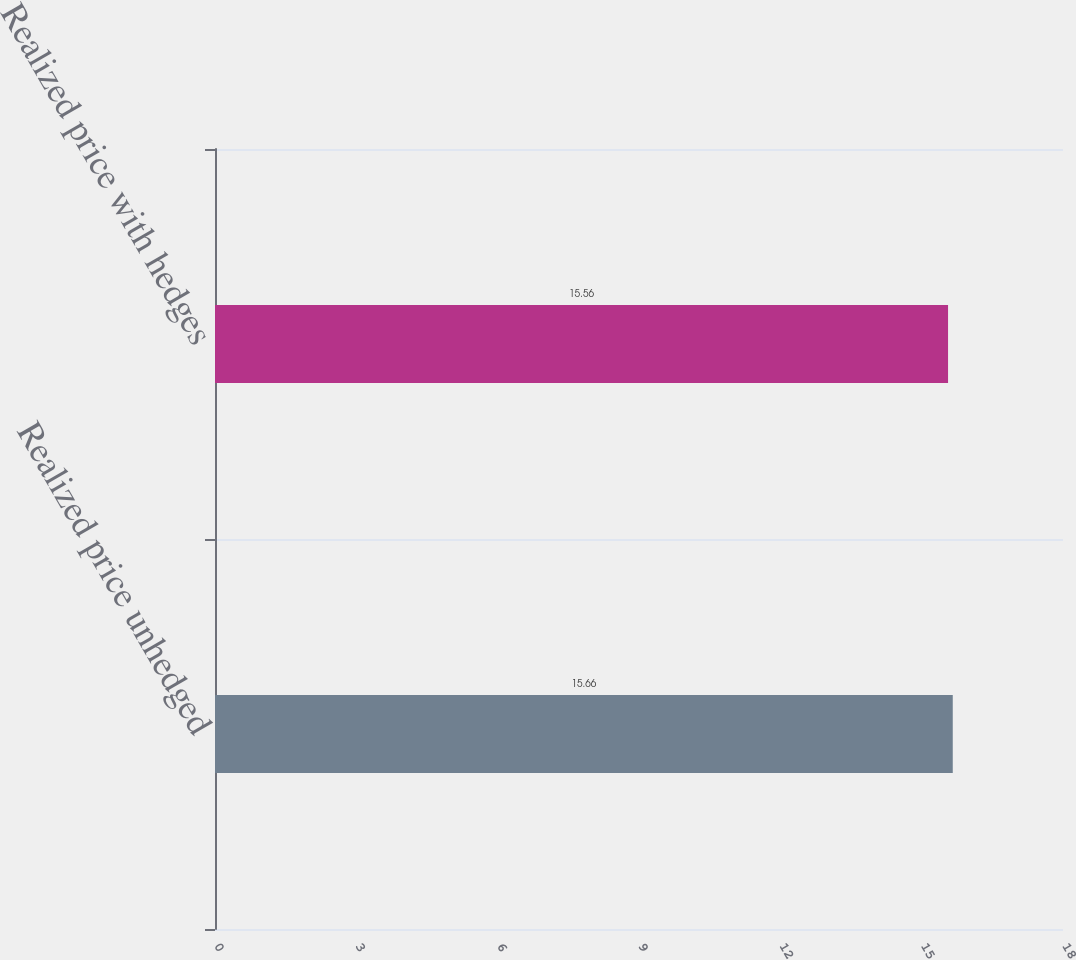Convert chart. <chart><loc_0><loc_0><loc_500><loc_500><bar_chart><fcel>Realized price unhedged<fcel>Realized price with hedges<nl><fcel>15.66<fcel>15.56<nl></chart> 